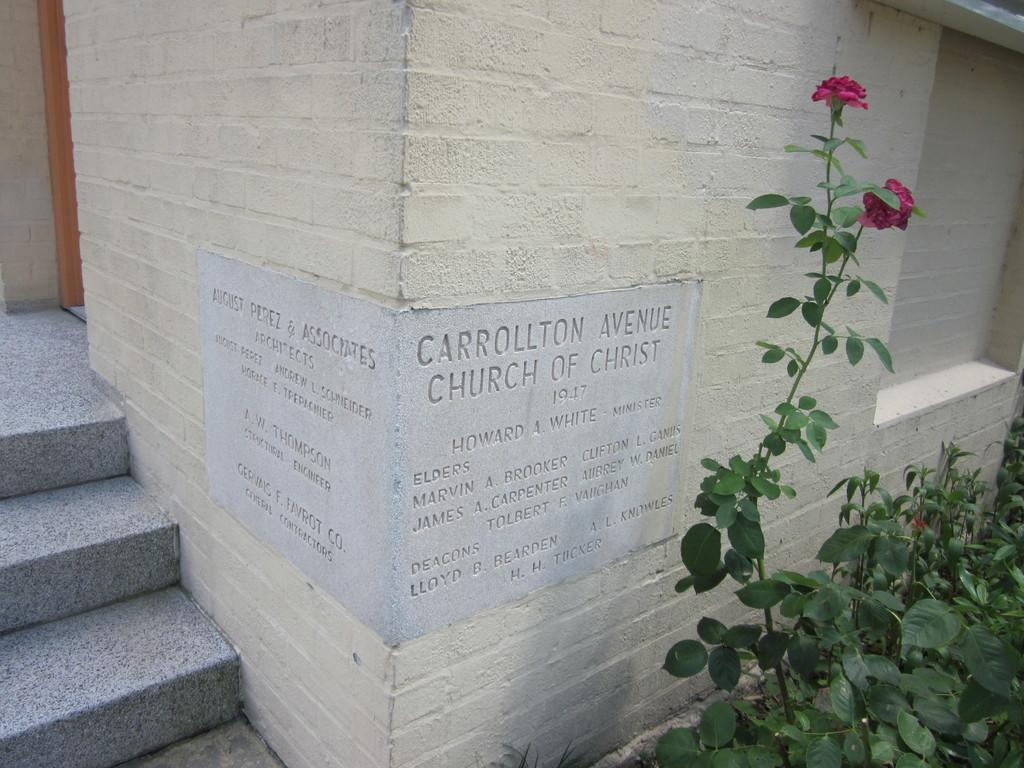What is written or depicted on the wall in the image? There is a wall with text in the image. What type of vegetation is present on the right side of the image? There are plants with flowers on the right side of the image. What architectural feature is located on the left side of the image? There are stairs on the left side of the image. What color is the crow perched on the lamp in the image? There is no crow or lamp present in the image. How many stockings are hanging on the wall in the image? There is no mention of stockings in the image; the wall has text on it. 